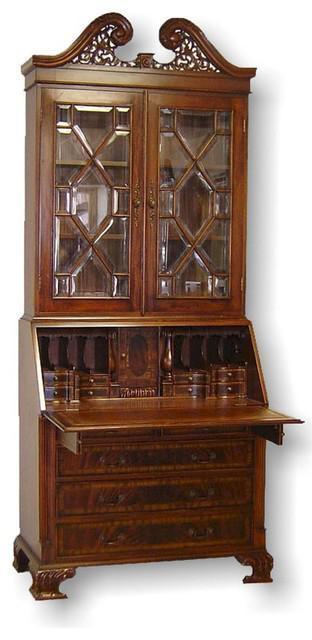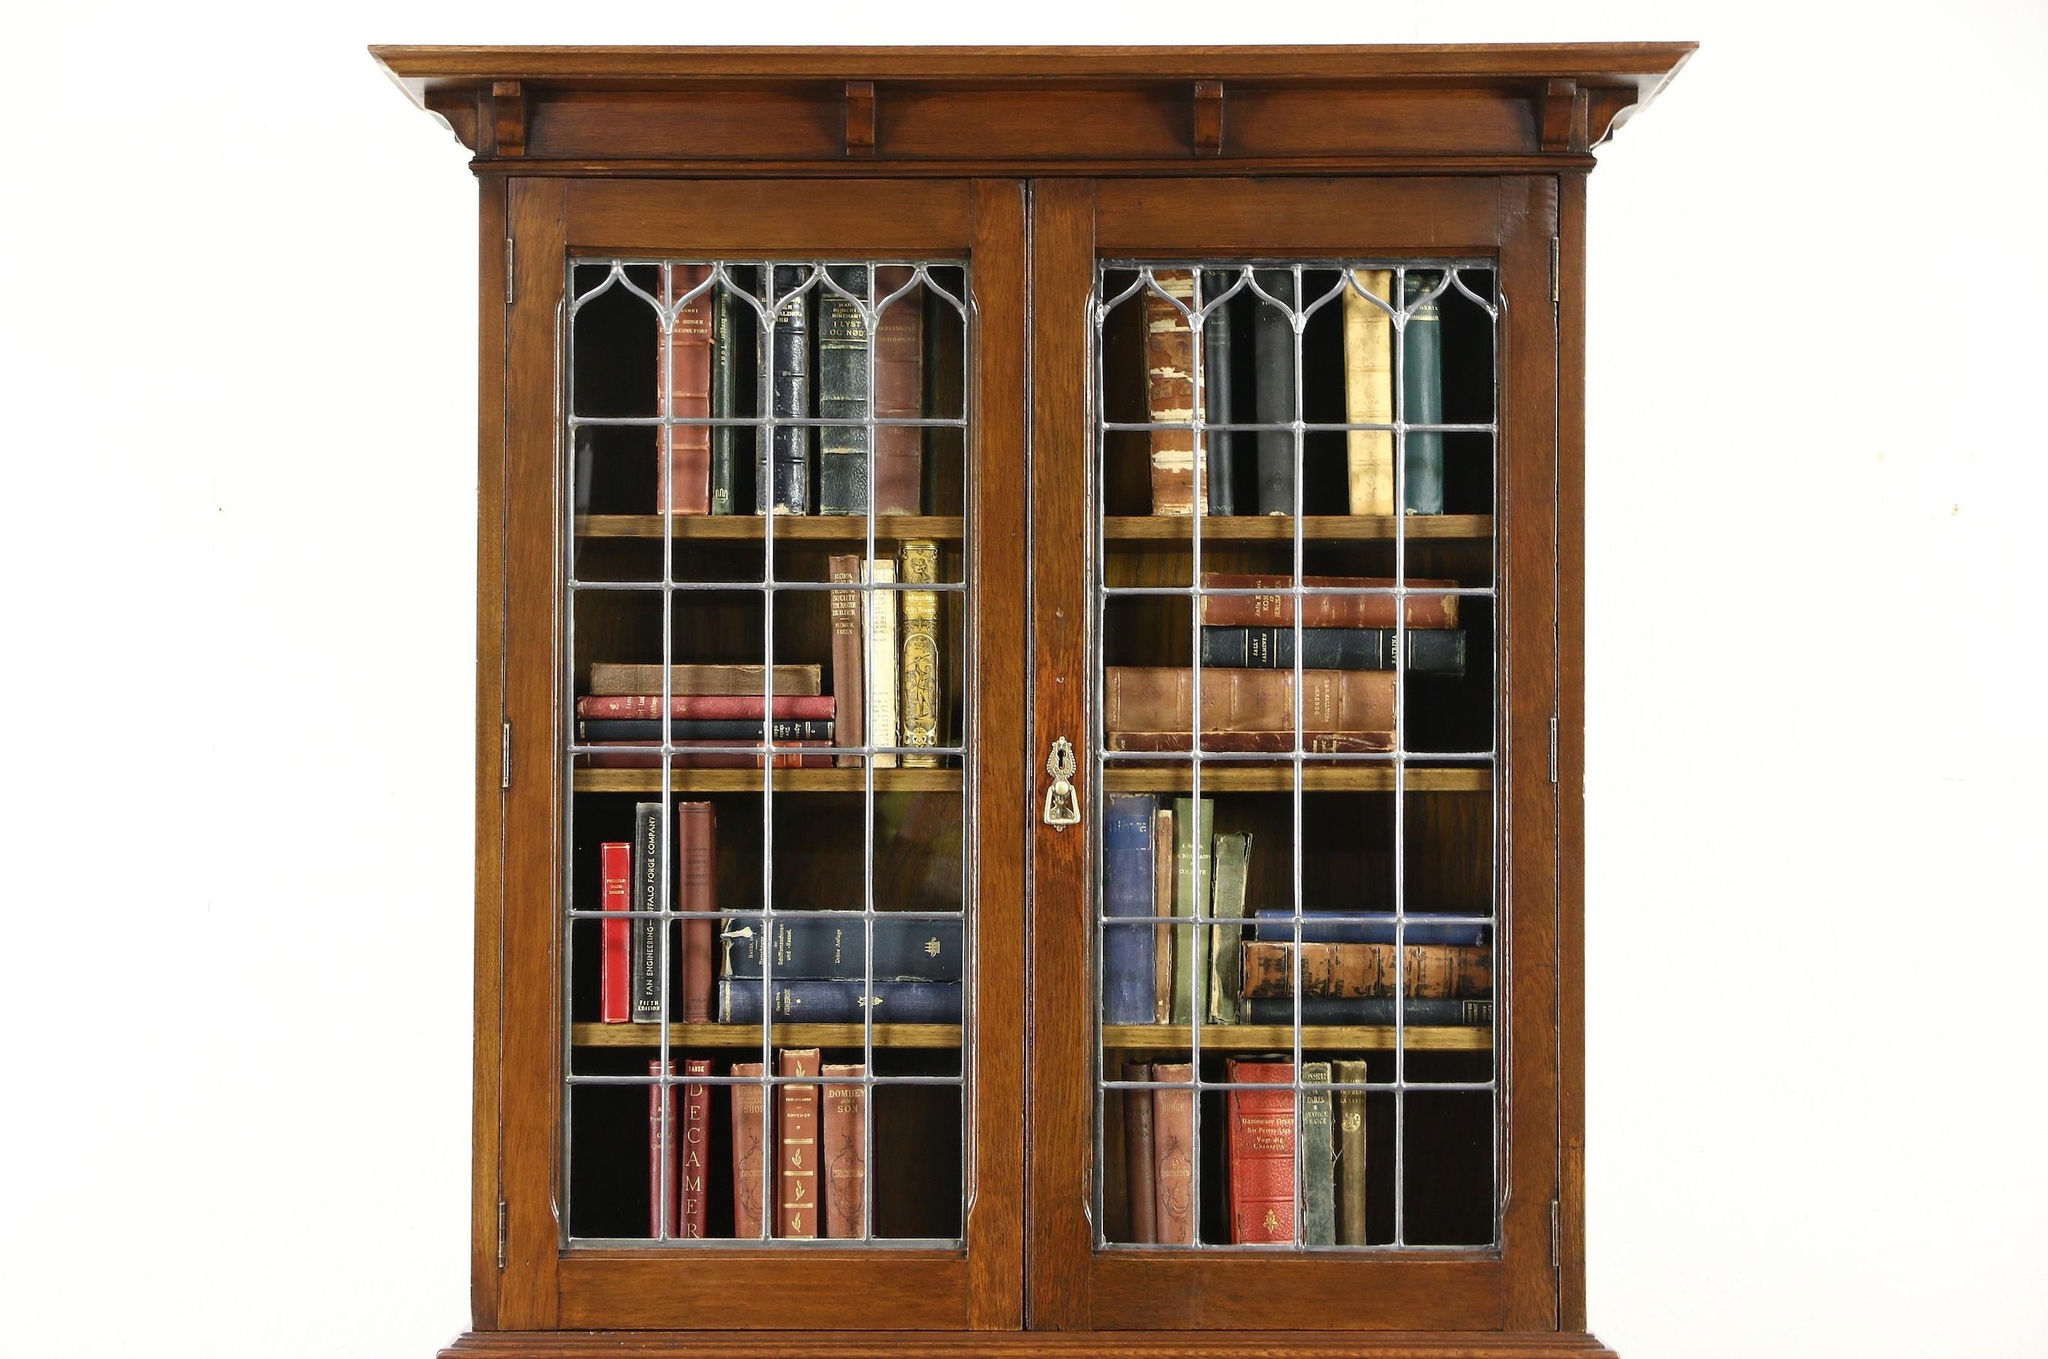The first image is the image on the left, the second image is the image on the right. Considering the images on both sides, is "there is a cabinet with a glass door n the left and a mirror and 3 drawers on the right" valid? Answer yes or no. No. The first image is the image on the left, the second image is the image on the right. Given the left and right images, does the statement "The hutch has side by side doors with window panels." hold true? Answer yes or no. Yes. 